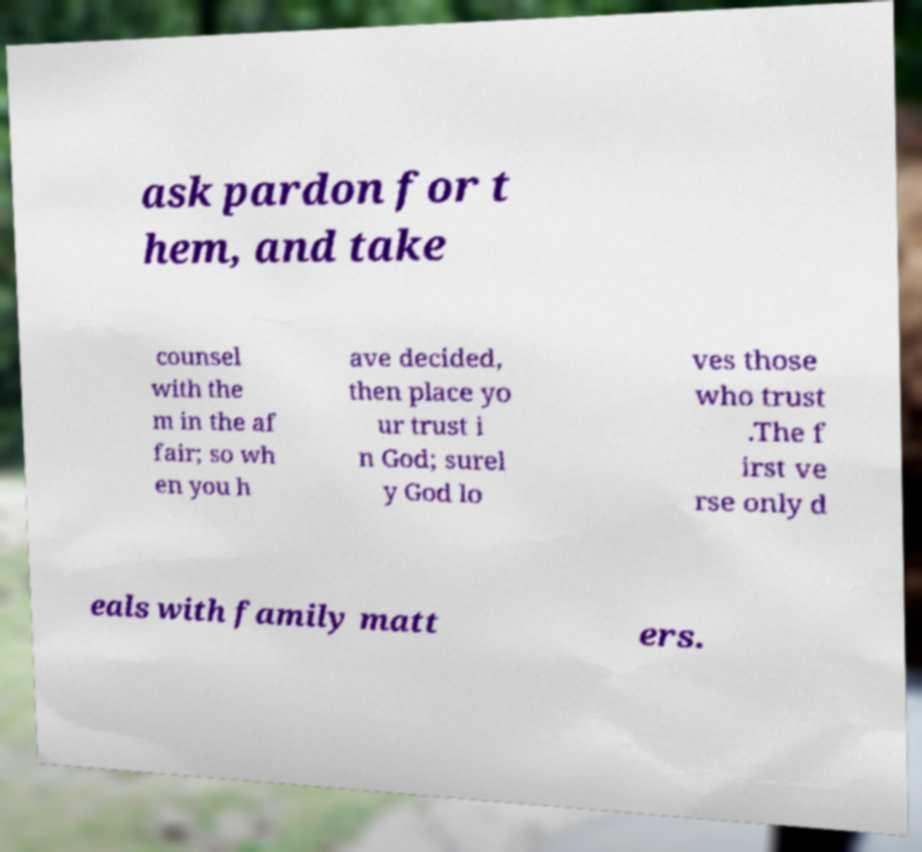I need the written content from this picture converted into text. Can you do that? ask pardon for t hem, and take counsel with the m in the af fair; so wh en you h ave decided, then place yo ur trust i n God; surel y God lo ves those who trust .The f irst ve rse only d eals with family matt ers. 